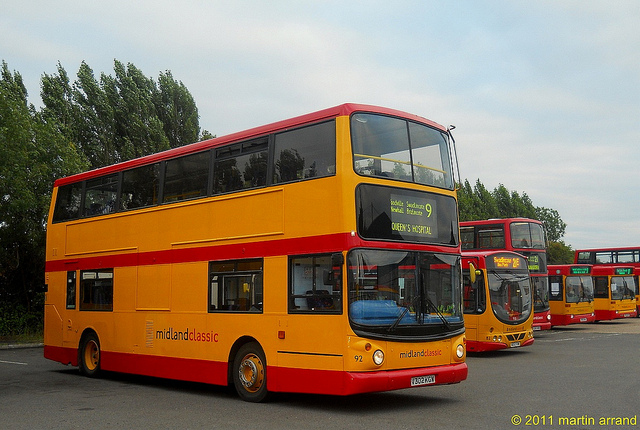Please identify all text content in this image. midland midlandclassic 92 9 arrand martin 2011 C 